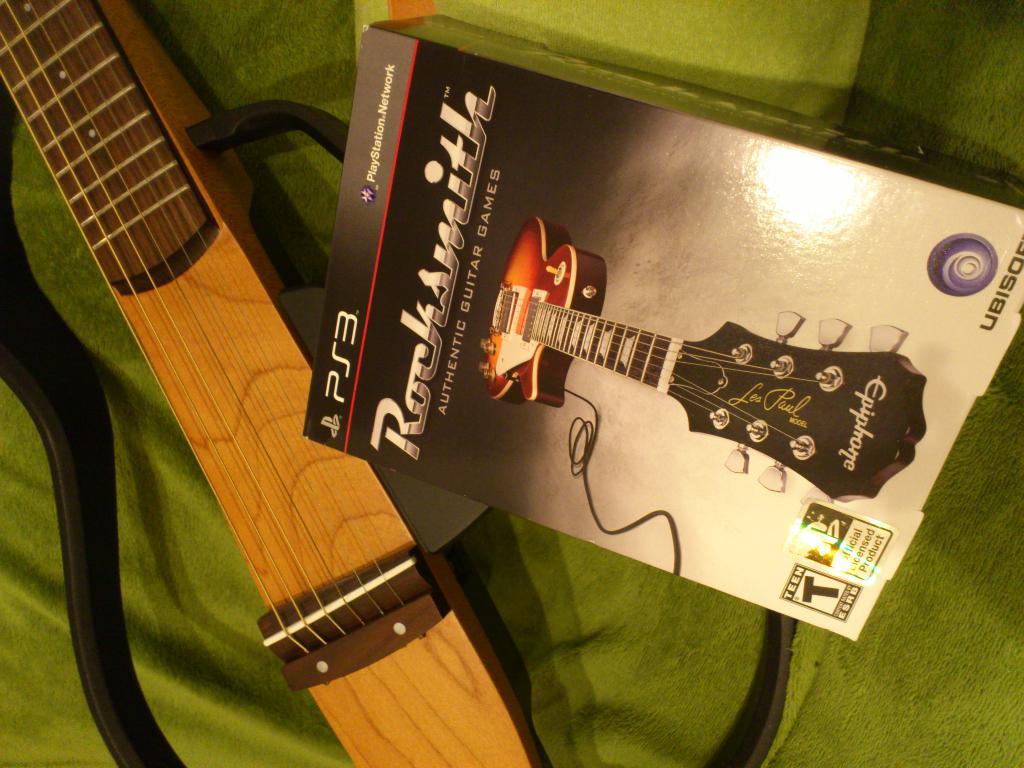What game system is this for?
Give a very brief answer. Ps3. 